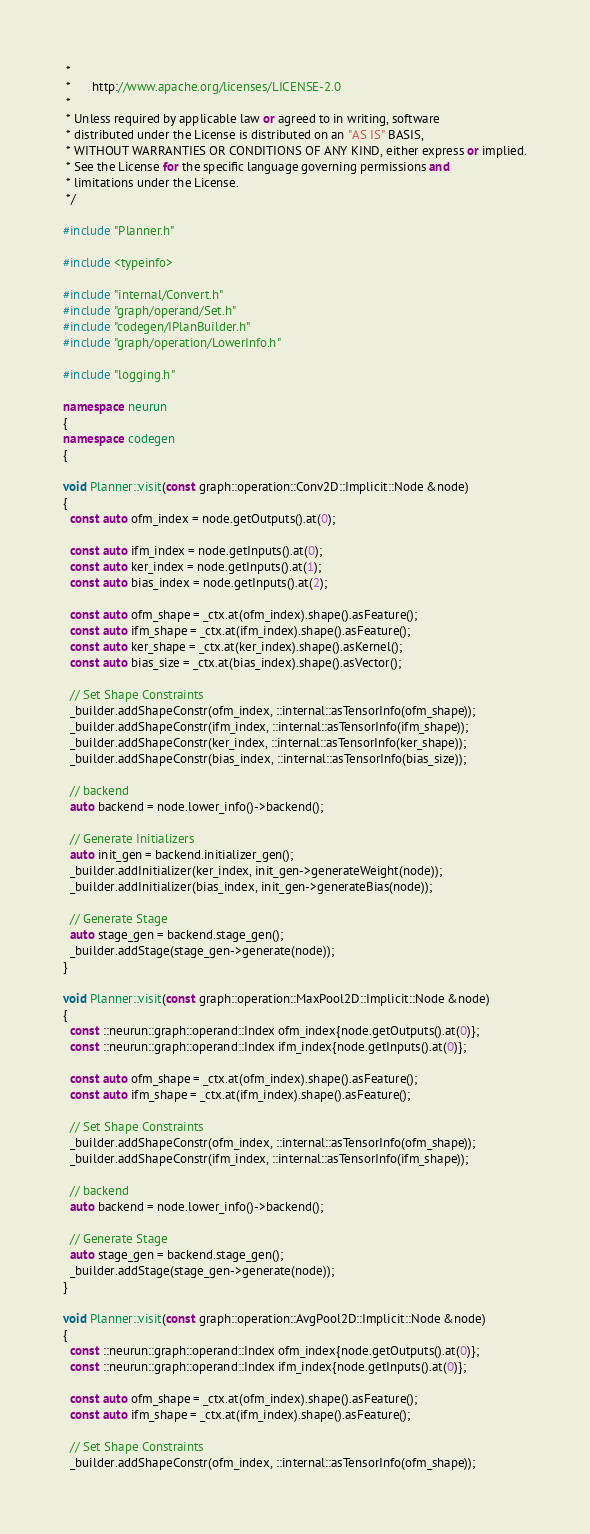<code> <loc_0><loc_0><loc_500><loc_500><_C++_> *
 *      http://www.apache.org/licenses/LICENSE-2.0
 *
 * Unless required by applicable law or agreed to in writing, software
 * distributed under the License is distributed on an "AS IS" BASIS,
 * WITHOUT WARRANTIES OR CONDITIONS OF ANY KIND, either express or implied.
 * See the License for the specific language governing permissions and
 * limitations under the License.
 */

#include "Planner.h"

#include <typeinfo>

#include "internal/Convert.h"
#include "graph/operand/Set.h"
#include "codegen/IPlanBuilder.h"
#include "graph/operation/LowerInfo.h"

#include "logging.h"

namespace neurun
{
namespace codegen
{

void Planner::visit(const graph::operation::Conv2D::Implicit::Node &node)
{
  const auto ofm_index = node.getOutputs().at(0);

  const auto ifm_index = node.getInputs().at(0);
  const auto ker_index = node.getInputs().at(1);
  const auto bias_index = node.getInputs().at(2);

  const auto ofm_shape = _ctx.at(ofm_index).shape().asFeature();
  const auto ifm_shape = _ctx.at(ifm_index).shape().asFeature();
  const auto ker_shape = _ctx.at(ker_index).shape().asKernel();
  const auto bias_size = _ctx.at(bias_index).shape().asVector();

  // Set Shape Constraints
  _builder.addShapeConstr(ofm_index, ::internal::asTensorInfo(ofm_shape));
  _builder.addShapeConstr(ifm_index, ::internal::asTensorInfo(ifm_shape));
  _builder.addShapeConstr(ker_index, ::internal::asTensorInfo(ker_shape));
  _builder.addShapeConstr(bias_index, ::internal::asTensorInfo(bias_size));

  // backend
  auto backend = node.lower_info()->backend();

  // Generate Initializers
  auto init_gen = backend.initializer_gen();
  _builder.addInitializer(ker_index, init_gen->generateWeight(node));
  _builder.addInitializer(bias_index, init_gen->generateBias(node));

  // Generate Stage
  auto stage_gen = backend.stage_gen();
  _builder.addStage(stage_gen->generate(node));
}

void Planner::visit(const graph::operation::MaxPool2D::Implicit::Node &node)
{
  const ::neurun::graph::operand::Index ofm_index{node.getOutputs().at(0)};
  const ::neurun::graph::operand::Index ifm_index{node.getInputs().at(0)};

  const auto ofm_shape = _ctx.at(ofm_index).shape().asFeature();
  const auto ifm_shape = _ctx.at(ifm_index).shape().asFeature();

  // Set Shape Constraints
  _builder.addShapeConstr(ofm_index, ::internal::asTensorInfo(ofm_shape));
  _builder.addShapeConstr(ifm_index, ::internal::asTensorInfo(ifm_shape));

  // backend
  auto backend = node.lower_info()->backend();

  // Generate Stage
  auto stage_gen = backend.stage_gen();
  _builder.addStage(stage_gen->generate(node));
}

void Planner::visit(const graph::operation::AvgPool2D::Implicit::Node &node)
{
  const ::neurun::graph::operand::Index ofm_index{node.getOutputs().at(0)};
  const ::neurun::graph::operand::Index ifm_index{node.getInputs().at(0)};

  const auto ofm_shape = _ctx.at(ofm_index).shape().asFeature();
  const auto ifm_shape = _ctx.at(ifm_index).shape().asFeature();

  // Set Shape Constraints
  _builder.addShapeConstr(ofm_index, ::internal::asTensorInfo(ofm_shape));</code> 